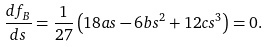Convert formula to latex. <formula><loc_0><loc_0><loc_500><loc_500>\frac { d f _ { B } } { d s } = \frac { 1 } { 2 7 } \left ( 1 8 a s - 6 b s ^ { 2 } + 1 2 c s ^ { 3 } \right ) = 0 .</formula> 